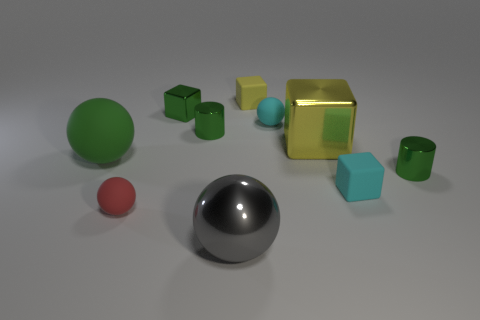Subtract 2 spheres. How many spheres are left? 2 Subtract all yellow balls. Subtract all purple cylinders. How many balls are left? 4 Subtract all spheres. How many objects are left? 6 Add 4 rubber things. How many rubber things exist? 9 Subtract 1 cyan balls. How many objects are left? 9 Subtract all gray things. Subtract all brown metallic objects. How many objects are left? 9 Add 7 tiny yellow objects. How many tiny yellow objects are left? 8 